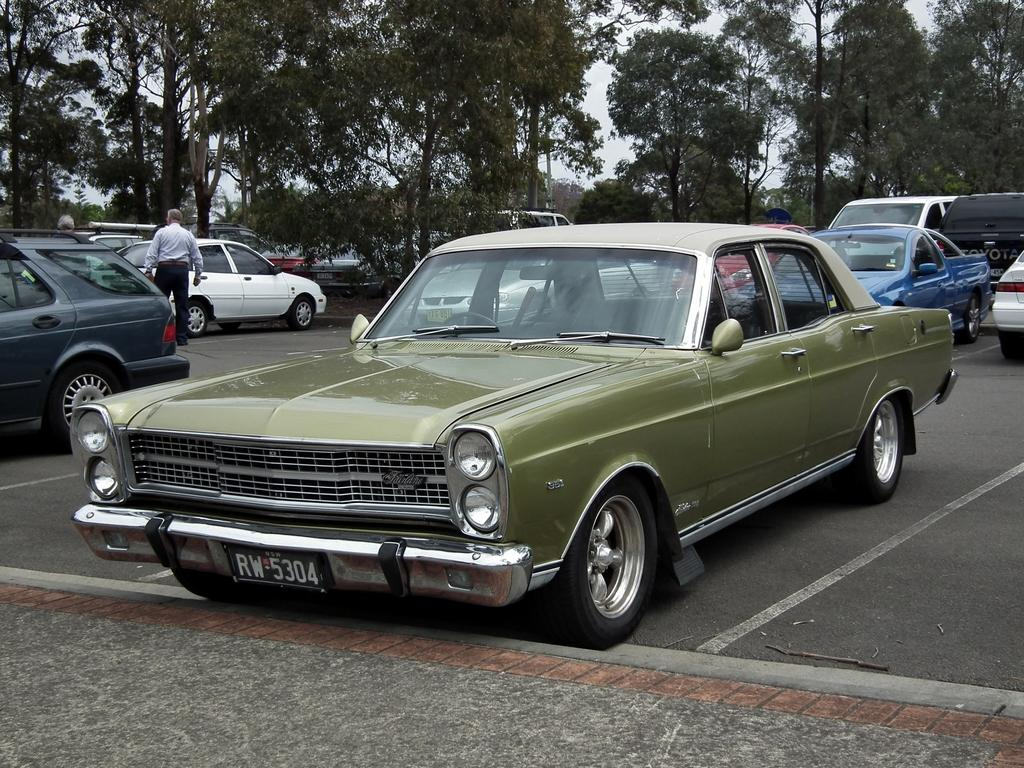What can be seen on the ground in the image? There are vehicles on the ground in the image. What type of natural elements are visible in the image? There are trees visible in the image. Can you describe the people in the image? There are persons in the image. What is visible in the background of the image? The sky is visible in the image. How many cakes are being served to the persons in the image? There is no mention of cakes in the image; it features vehicles, trees, persons, and the sky. What type of rest can be seen in the image? There is no rest or resting area visible in the image. 